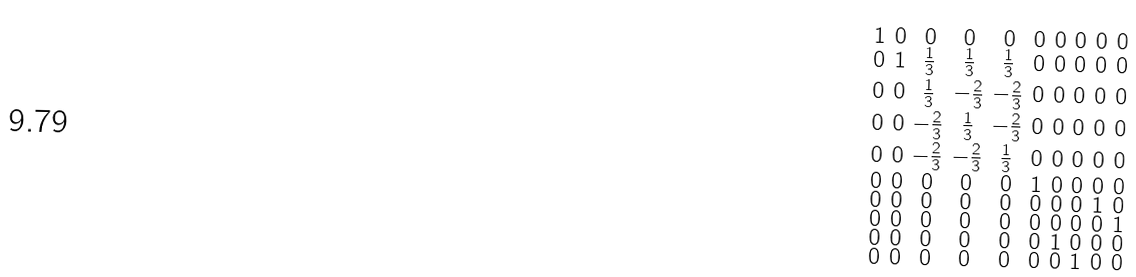Convert formula to latex. <formula><loc_0><loc_0><loc_500><loc_500>\begin{smallmatrix} 1 & 0 & 0 & 0 & 0 & 0 & 0 & 0 & 0 & 0 \\ 0 & 1 & \frac { 1 } { 3 } & \frac { 1 } { 3 } & \frac { 1 } { 3 } & 0 & 0 & 0 & 0 & 0 \\ 0 & 0 & \frac { 1 } { 3 } & - \frac { 2 } { 3 } & - \frac { 2 } { 3 } & 0 & 0 & 0 & 0 & 0 \\ 0 & 0 & - \frac { 2 } { 3 } & \frac { 1 } { 3 } & - \frac { 2 } { 3 } & 0 & 0 & 0 & 0 & 0 \\ 0 & 0 & - \frac { 2 } { 3 } & - \frac { 2 } { 3 } & \frac { 1 } { 3 } & 0 & 0 & 0 & 0 & 0 \\ 0 & 0 & 0 & 0 & 0 & 1 & 0 & 0 & 0 & 0 \\ 0 & 0 & 0 & 0 & 0 & 0 & 0 & 0 & 1 & 0 \\ 0 & 0 & 0 & 0 & 0 & 0 & 0 & 0 & 0 & 1 \\ 0 & 0 & 0 & 0 & 0 & 0 & 1 & 0 & 0 & 0 \\ 0 & 0 & 0 & 0 & 0 & 0 & 0 & 1 & 0 & 0 \end{smallmatrix}</formula> 